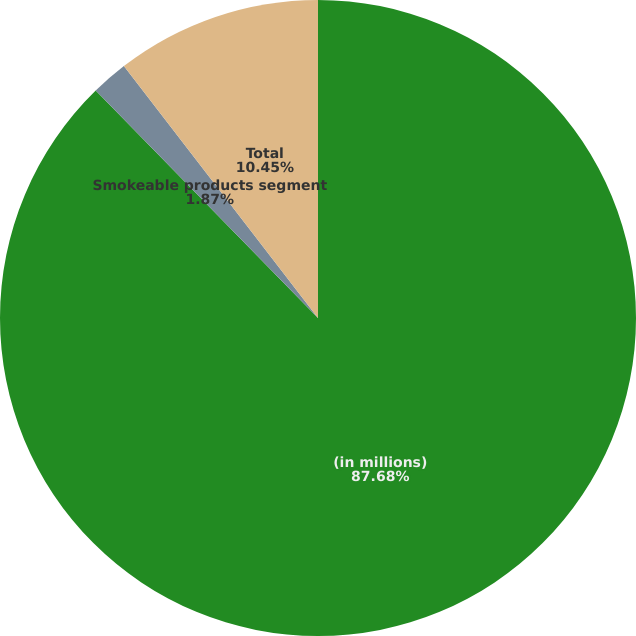<chart> <loc_0><loc_0><loc_500><loc_500><pie_chart><fcel>(in millions)<fcel>Smokeable products segment<fcel>Total<nl><fcel>87.68%<fcel>1.87%<fcel>10.45%<nl></chart> 